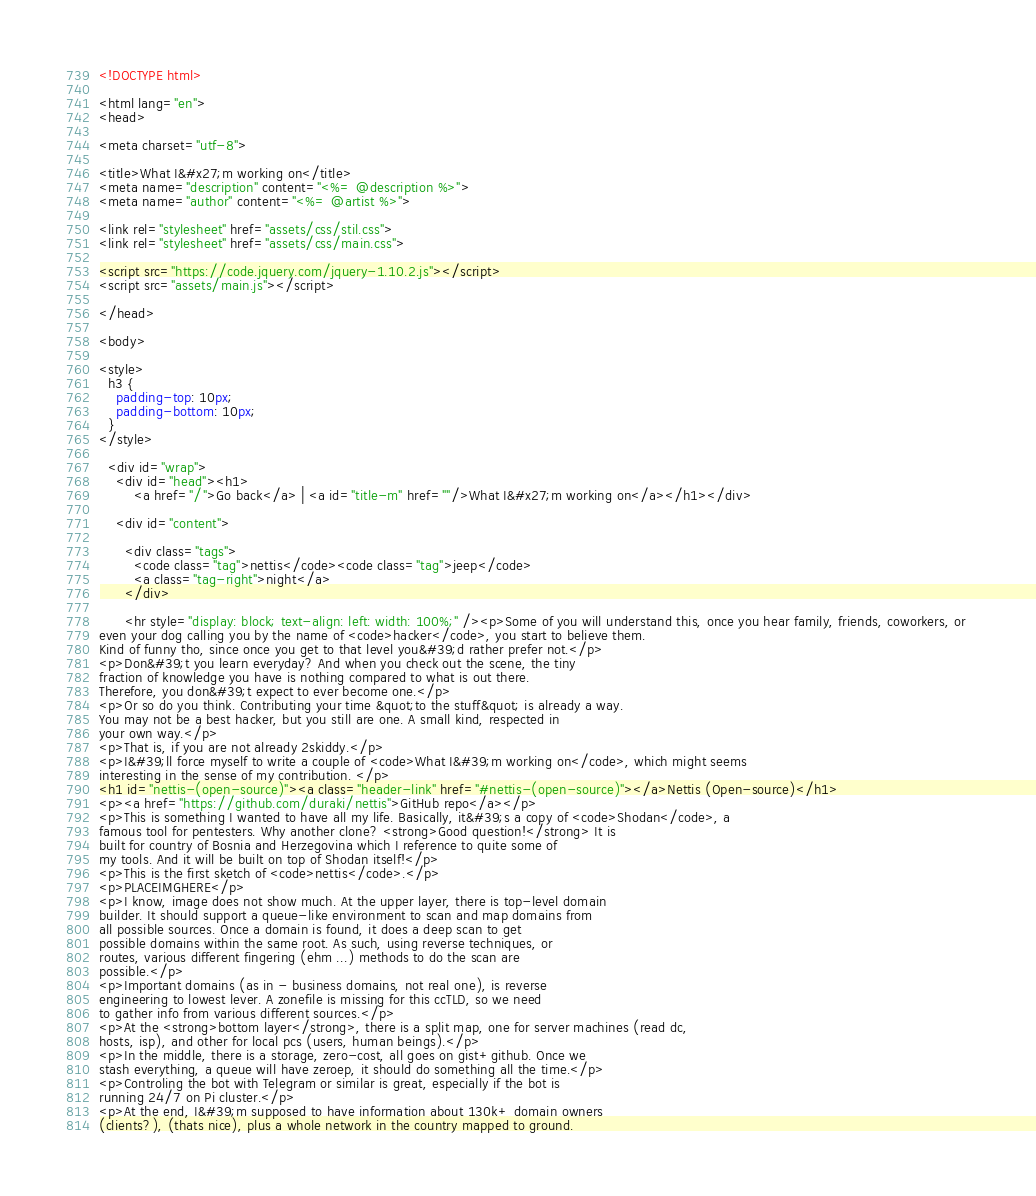Convert code to text. <code><loc_0><loc_0><loc_500><loc_500><_HTML_><!DOCTYPE html>

<html lang="en">
<head>

<meta charset="utf-8">

<title>What I&#x27;m working on</title>
<meta name="description" content="<%= @description %>">
<meta name="author" content="<%= @artist %>">

<link rel="stylesheet" href="assets/css/stil.css">
<link rel="stylesheet" href="assets/css/main.css">

<script src="https://code.jquery.com/jquery-1.10.2.js"></script>
<script src="assets/main.js"></script>

</head>

<body>

<style>
  h3 {
    padding-top: 10px;
    padding-bottom: 10px;
  }
</style>

  <div id="wrap">
    <div id="head"><h1>
        <a href="/">Go back</a> | <a id="title-m" href=""/>What I&#x27;m working on</a></h1></div>

    <div id="content">
    
      <div class="tags">
        <code class="tag">nettis</code><code class="tag">jeep</code>
        <a class="tag-right">night</a>
      </div>

      <hr style="display: block; text-align: left: width: 100%;" /><p>Some of you will understand this, once you hear family, friends, coworkers, or 
even your dog calling you by the name of <code>hacker</code>, you start to believe them.
Kind of funny tho, since once you get to that level you&#39;d rather prefer not.</p>
<p>Don&#39;t you learn everyday? And when you check out the scene, the tiny
fraction of knowledge you have is nothing compared to what is out there.
Therefore, you don&#39;t expect to ever become one.</p>
<p>Or so do you think. Contributing your time &quot;to the stuff&quot; is already a way. 
You may not be a best hacker, but you still are one. A small kind, respected in 
your own way.</p>
<p>That is, if you are not already 2skiddy.</p>
<p>I&#39;ll force myself to write a couple of <code>What I&#39;m working on</code>, which might seems
interesting in the sense of my contribution. </p>
<h1 id="nettis-(open-source)"><a class="header-link" href="#nettis-(open-source)"></a>Nettis (Open-source)</h1>
<p><a href="https://github.com/duraki/nettis">GitHub repo</a></p>
<p>This is something I wanted to have all my life. Basically, it&#39;s a copy of <code>Shodan</code>, a
famous tool for pentesters. Why another clone? <strong>Good question!</strong> It is
built for country of Bosnia and Herzegovina which I reference to quite some of
my tools. And it will be built on top of Shodan itself!</p>
<p>This is the first sketch of <code>nettis</code>.</p>
<p>PLACEIMGHERE</p>
<p>I know, image does not show much. At the upper layer, there is top-level domain
builder. It should support a queue-like environment to scan and map domains from
all possible sources. Once a domain is found, it does a deep scan to get
possible domains within the same root. As such, using reverse techniques, or
routes, various different fingering (ehm ...) methods to do the scan are
possible.</p>
<p>Important domains (as in - business domains, not real one), is reverse
engineering to lowest lever. A zonefile is missing for this ccTLD, so we need
to gather info from various different sources.</p>
<p>At the <strong>bottom layer</strong>, there is a split map, one for server machines (read dc, 
hosts, isp), and other for local pcs (users, human beings).</p>
<p>In the middle, there is a storage, zero-cost, all goes on gist+github. Once we
stash everything, a queue will have zeroep, it should do something all the time.</p>
<p>Controling the bot with Telegram or similar is great, especially if the bot is
running 24/7 on Pi cluster.</p>
<p>At the end, I&#39;m supposed to have information about 130k+ domain owners
(clients?), (thats nice), plus a whole network in the country mapped to ground. </code> 